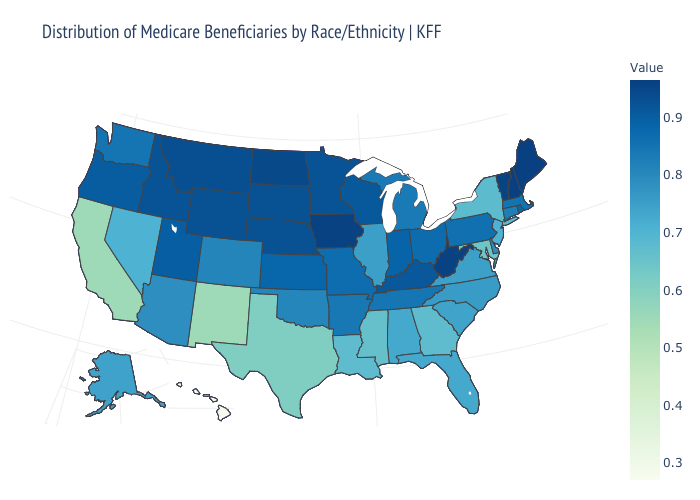Does Hawaii have the lowest value in the West?
Keep it brief. Yes. Does New Hampshire have the highest value in the USA?
Give a very brief answer. No. Which states hav the highest value in the Northeast?
Quick response, please. Maine. Does New York have the lowest value in the Northeast?
Give a very brief answer. Yes. Among the states that border Rhode Island , does Connecticut have the highest value?
Short answer required. No. Which states have the highest value in the USA?
Write a very short answer. Maine. Among the states that border West Virginia , which have the lowest value?
Write a very short answer. Maryland. 